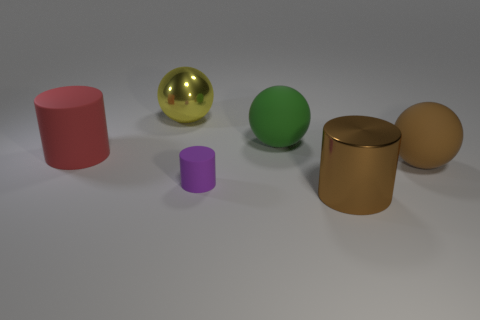Are there more shiny cylinders behind the yellow shiny thing than red things? Upon examining the image, there are no shiny cylinders behind the yellow shiny sphere. In fact, the only cylinders present are a red one and a gold-colored one, positioned to the left of the yellow shiny sphere, and there are no red things behind it. Additionally, the red cylinder is in front of the yellow object, not behind it. 